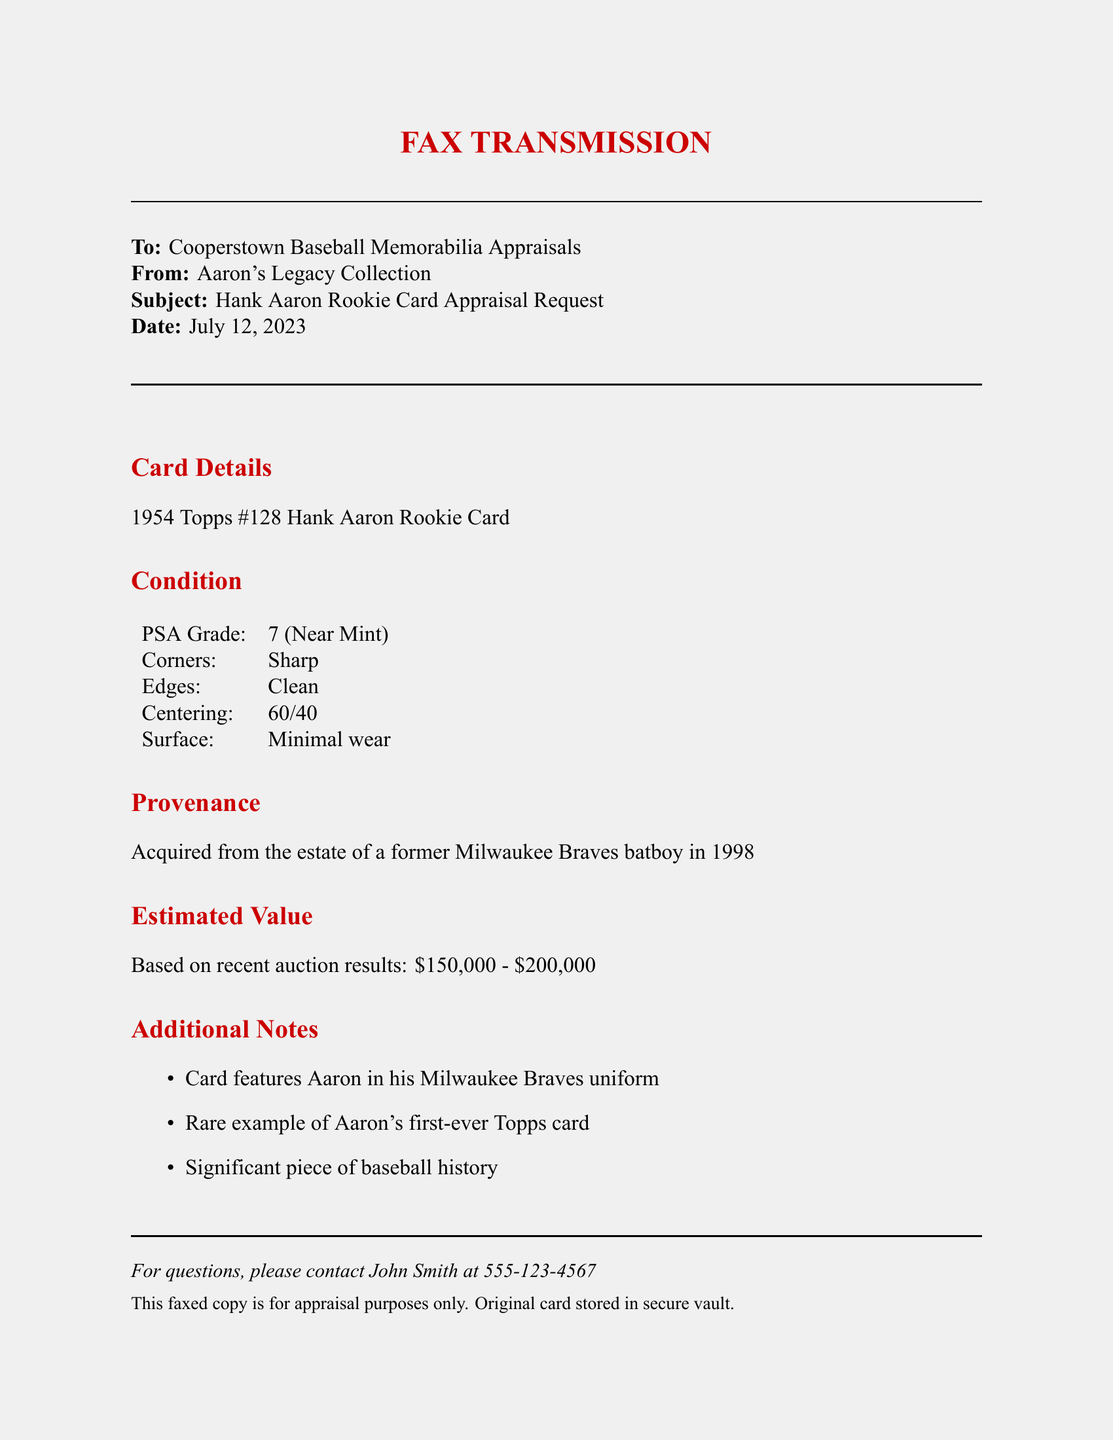What is the year of the Hank Aaron rookie card? The document states that the card is from the year 1954.
Answer: 1954 What is the PSA grade of the card? The document indicates that the card has a PSA Grade of 7 (Near Mint).
Answer: 7 (Near Mint) What is the estimated value range of the card? The estimated value based on recent auction results is mentioned in the document as $150,000 - $200,000.
Answer: $150,000 - $200,000 Who was the card acquired from? The document states that the card was acquired from the estate of a former Milwaukee Braves batboy.
Answer: former Milwaukee Braves batboy What is the centering percentage of the card? The document provides the centering percentage as 60/40.
Answer: 60/40 What feature of the card indicates its historical significance? The document notes that it is a rare example of Aaron's first-ever Topps card.
Answer: first-ever Topps card What color is the fax cover page? The document specifies the page color as fax gray.
Answer: fax gray Which team is Hank Aaron depicted in? The document specifies that the card features Aaron in his Milwaukee Braves uniform.
Answer: Milwaukee Braves Who should be contacted for questions about the fax? The document provides contact information for John Smith regarding questions.
Answer: John Smith 